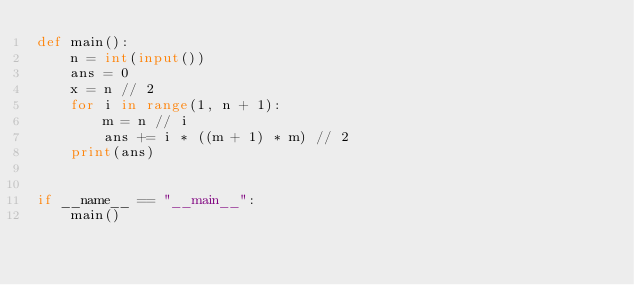Convert code to text. <code><loc_0><loc_0><loc_500><loc_500><_Python_>def main():
    n = int(input())
    ans = 0
    x = n // 2
    for i in range(1, n + 1):
        m = n // i
        ans += i * ((m + 1) * m) // 2
    print(ans)


if __name__ == "__main__":
    main()
</code> 